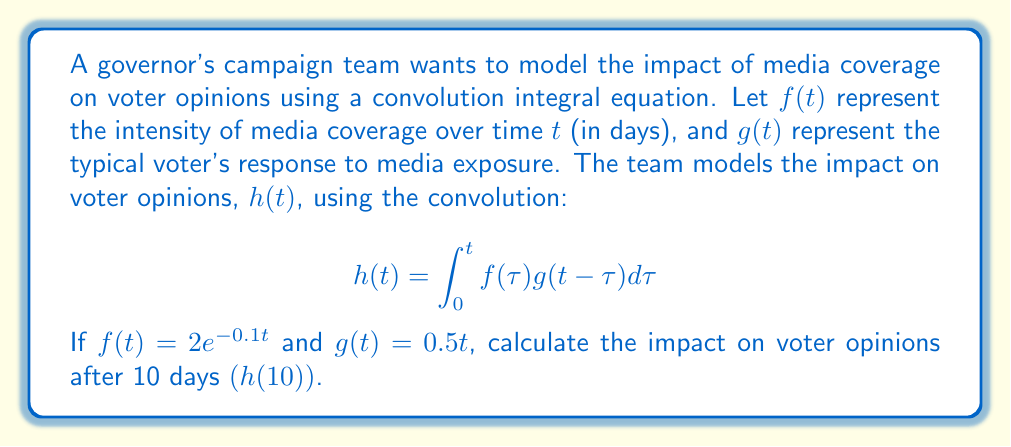Provide a solution to this math problem. To solve this problem, we'll follow these steps:

1) We have the convolution integral:
   $$h(t) = \int_0^t f(\tau)g(t-\tau)d\tau$$

2) Substitute the given functions:
   $$h(10) = \int_0^{10} (2e^{-0.1\tau})(0.5(10-\tau))d\tau$$

3) Simplify:
   $$h(10) = \int_0^{10} e^{-0.1\tau}(5-0.5\tau)d\tau$$

4) Expand the integrand:
   $$h(10) = \int_0^{10} (5e^{-0.1\tau} - 0.5\tau e^{-0.1\tau})d\tau$$

5) Integrate each term separately:
   $$h(10) = \left[-50e^{-0.1\tau}\right]_0^{10} - \int_0^{10} 0.5\tau e^{-0.1\tau}d\tau$$

6) For the second integral, use integration by parts:
   Let $u = \tau$ and $dv = e^{-0.1\tau}d\tau$
   Then $du = d\tau$ and $v = -10e^{-0.1\tau}$

   $$\int_0^{10} 0.5\tau e^{-0.1\tau}d\tau = -5\tau e^{-0.1\tau}\Big|_0^{10} + 50\int_0^{10} e^{-0.1\tau}d\tau$$

7) Evaluate the integrals:
   $$h(10) = [-50e^{-1} + 50] - [-50e^{-1} + 0 + 500e^{-1} - 500]$$

8) Simplify:
   $$h(10) = 50 - 50e^{-1} + 50e^{-1} + 500 - 500e^{-1}$$
   $$h(10) = 550 - 500e^{-1}$$

9) Calculate the final value:
   $$h(10) \approx 365.49$$
Answer: 365.49 